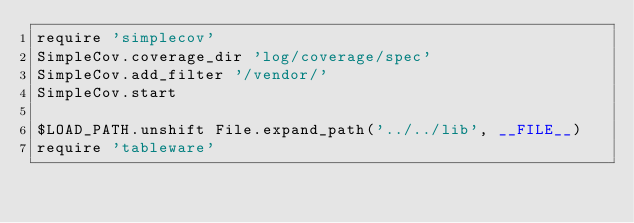<code> <loc_0><loc_0><loc_500><loc_500><_Ruby_>require 'simplecov'
SimpleCov.coverage_dir 'log/coverage/spec'
SimpleCov.add_filter '/vendor/'
SimpleCov.start

$LOAD_PATH.unshift File.expand_path('../../lib', __FILE__)
require 'tableware'
</code> 